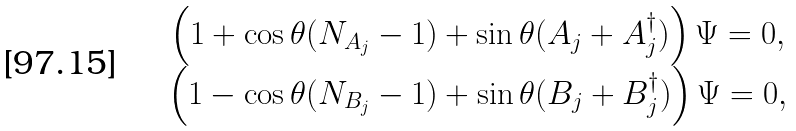Convert formula to latex. <formula><loc_0><loc_0><loc_500><loc_500>\begin{array} { c } \left ( 1 + \cos \theta ( N _ { A _ { j } } - 1 ) + \sin \theta ( A _ { j } + A ^ { \dagger } _ { j } ) \right ) \Psi = 0 , \\ \left ( 1 - \cos \theta ( N _ { B _ { j } } - 1 ) + \sin \theta ( B _ { j } + B ^ { \dagger } _ { j } ) \right ) \Psi = 0 , \end{array}</formula> 